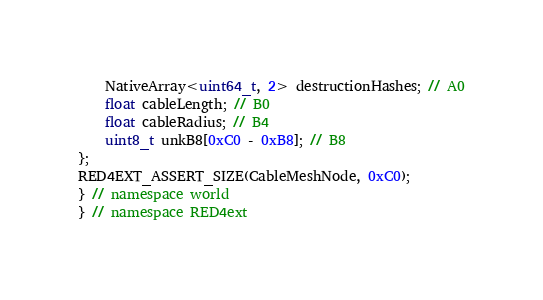<code> <loc_0><loc_0><loc_500><loc_500><_C++_>    NativeArray<uint64_t, 2> destructionHashes; // A0
    float cableLength; // B0
    float cableRadius; // B4
    uint8_t unkB8[0xC0 - 0xB8]; // B8
};
RED4EXT_ASSERT_SIZE(CableMeshNode, 0xC0);
} // namespace world
} // namespace RED4ext
</code> 